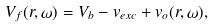<formula> <loc_0><loc_0><loc_500><loc_500>V _ { f } ( { r } , \omega ) = V _ { b } - v _ { e x c } + v _ { o } ( { r } , \omega ) ,</formula> 